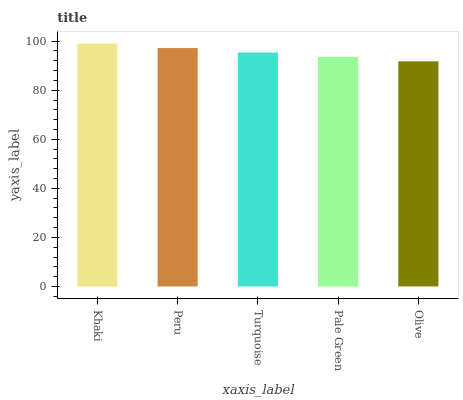Is Olive the minimum?
Answer yes or no. Yes. Is Khaki the maximum?
Answer yes or no. Yes. Is Peru the minimum?
Answer yes or no. No. Is Peru the maximum?
Answer yes or no. No. Is Khaki greater than Peru?
Answer yes or no. Yes. Is Peru less than Khaki?
Answer yes or no. Yes. Is Peru greater than Khaki?
Answer yes or no. No. Is Khaki less than Peru?
Answer yes or no. No. Is Turquoise the high median?
Answer yes or no. Yes. Is Turquoise the low median?
Answer yes or no. Yes. Is Khaki the high median?
Answer yes or no. No. Is Khaki the low median?
Answer yes or no. No. 